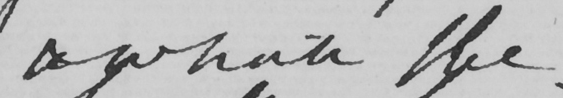Transcribe the text shown in this historical manuscript line. & while the 